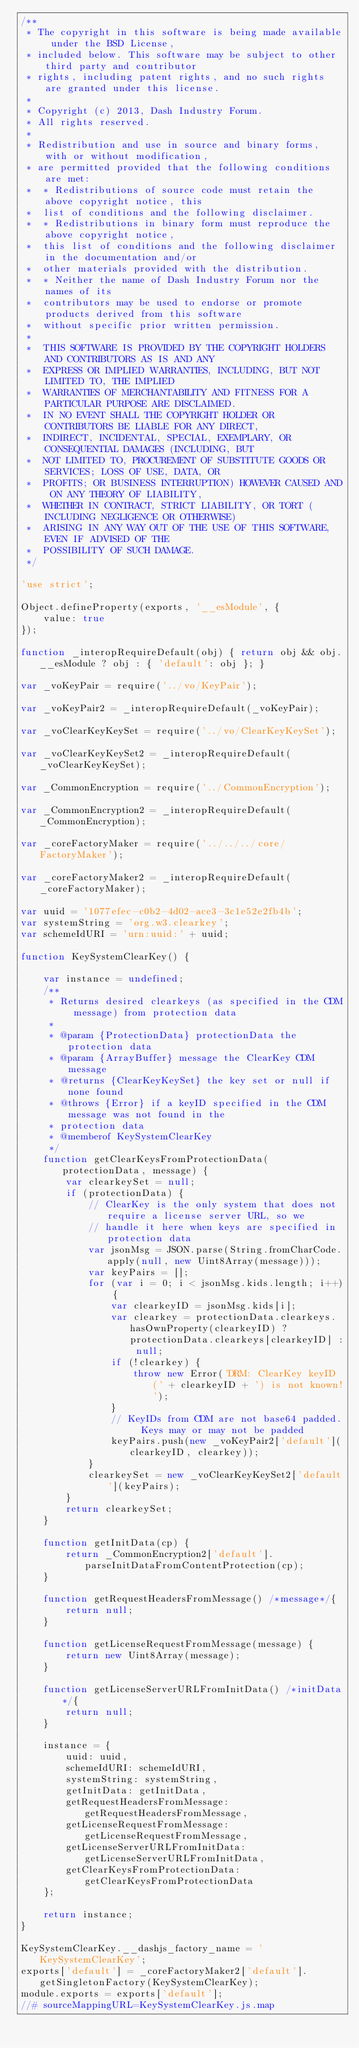<code> <loc_0><loc_0><loc_500><loc_500><_JavaScript_>/**
 * The copyright in this software is being made available under the BSD License,
 * included below. This software may be subject to other third party and contributor
 * rights, including patent rights, and no such rights are granted under this license.
 *
 * Copyright (c) 2013, Dash Industry Forum.
 * All rights reserved.
 *
 * Redistribution and use in source and binary forms, with or without modification,
 * are permitted provided that the following conditions are met:
 *  * Redistributions of source code must retain the above copyright notice, this
 *  list of conditions and the following disclaimer.
 *  * Redistributions in binary form must reproduce the above copyright notice,
 *  this list of conditions and the following disclaimer in the documentation and/or
 *  other materials provided with the distribution.
 *  * Neither the name of Dash Industry Forum nor the names of its
 *  contributors may be used to endorse or promote products derived from this software
 *  without specific prior written permission.
 *
 *  THIS SOFTWARE IS PROVIDED BY THE COPYRIGHT HOLDERS AND CONTRIBUTORS AS IS AND ANY
 *  EXPRESS OR IMPLIED WARRANTIES, INCLUDING, BUT NOT LIMITED TO, THE IMPLIED
 *  WARRANTIES OF MERCHANTABILITY AND FITNESS FOR A PARTICULAR PURPOSE ARE DISCLAIMED.
 *  IN NO EVENT SHALL THE COPYRIGHT HOLDER OR CONTRIBUTORS BE LIABLE FOR ANY DIRECT,
 *  INDIRECT, INCIDENTAL, SPECIAL, EXEMPLARY, OR CONSEQUENTIAL DAMAGES (INCLUDING, BUT
 *  NOT LIMITED TO, PROCUREMENT OF SUBSTITUTE GOODS OR SERVICES; LOSS OF USE, DATA, OR
 *  PROFITS; OR BUSINESS INTERRUPTION) HOWEVER CAUSED AND ON ANY THEORY OF LIABILITY,
 *  WHETHER IN CONTRACT, STRICT LIABILITY, OR TORT (INCLUDING NEGLIGENCE OR OTHERWISE)
 *  ARISING IN ANY WAY OUT OF THE USE OF THIS SOFTWARE, EVEN IF ADVISED OF THE
 *  POSSIBILITY OF SUCH DAMAGE.
 */

'use strict';

Object.defineProperty(exports, '__esModule', {
    value: true
});

function _interopRequireDefault(obj) { return obj && obj.__esModule ? obj : { 'default': obj }; }

var _voKeyPair = require('../vo/KeyPair');

var _voKeyPair2 = _interopRequireDefault(_voKeyPair);

var _voClearKeyKeySet = require('../vo/ClearKeyKeySet');

var _voClearKeyKeySet2 = _interopRequireDefault(_voClearKeyKeySet);

var _CommonEncryption = require('../CommonEncryption');

var _CommonEncryption2 = _interopRequireDefault(_CommonEncryption);

var _coreFactoryMaker = require('../../../core/FactoryMaker');

var _coreFactoryMaker2 = _interopRequireDefault(_coreFactoryMaker);

var uuid = '1077efec-c0b2-4d02-ace3-3c1e52e2fb4b';
var systemString = 'org.w3.clearkey';
var schemeIdURI = 'urn:uuid:' + uuid;

function KeySystemClearKey() {

    var instance = undefined;
    /**
     * Returns desired clearkeys (as specified in the CDM message) from protection data
     *
     * @param {ProtectionData} protectionData the protection data
     * @param {ArrayBuffer} message the ClearKey CDM message
     * @returns {ClearKeyKeySet} the key set or null if none found
     * @throws {Error} if a keyID specified in the CDM message was not found in the
     * protection data
     * @memberof KeySystemClearKey
     */
    function getClearKeysFromProtectionData(protectionData, message) {
        var clearkeySet = null;
        if (protectionData) {
            // ClearKey is the only system that does not require a license server URL, so we
            // handle it here when keys are specified in protection data
            var jsonMsg = JSON.parse(String.fromCharCode.apply(null, new Uint8Array(message)));
            var keyPairs = [];
            for (var i = 0; i < jsonMsg.kids.length; i++) {
                var clearkeyID = jsonMsg.kids[i];
                var clearkey = protectionData.clearkeys.hasOwnProperty(clearkeyID) ? protectionData.clearkeys[clearkeyID] : null;
                if (!clearkey) {
                    throw new Error('DRM: ClearKey keyID (' + clearkeyID + ') is not known!');
                }
                // KeyIDs from CDM are not base64 padded.  Keys may or may not be padded
                keyPairs.push(new _voKeyPair2['default'](clearkeyID, clearkey));
            }
            clearkeySet = new _voClearKeyKeySet2['default'](keyPairs);
        }
        return clearkeySet;
    }

    function getInitData(cp) {
        return _CommonEncryption2['default'].parseInitDataFromContentProtection(cp);
    }

    function getRequestHeadersFromMessage() /*message*/{
        return null;
    }

    function getLicenseRequestFromMessage(message) {
        return new Uint8Array(message);
    }

    function getLicenseServerURLFromInitData() /*initData*/{
        return null;
    }

    instance = {
        uuid: uuid,
        schemeIdURI: schemeIdURI,
        systemString: systemString,
        getInitData: getInitData,
        getRequestHeadersFromMessage: getRequestHeadersFromMessage,
        getLicenseRequestFromMessage: getLicenseRequestFromMessage,
        getLicenseServerURLFromInitData: getLicenseServerURLFromInitData,
        getClearKeysFromProtectionData: getClearKeysFromProtectionData
    };

    return instance;
}

KeySystemClearKey.__dashjs_factory_name = 'KeySystemClearKey';
exports['default'] = _coreFactoryMaker2['default'].getSingletonFactory(KeySystemClearKey);
module.exports = exports['default'];
//# sourceMappingURL=KeySystemClearKey.js.map
</code> 